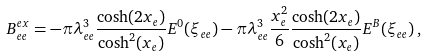<formula> <loc_0><loc_0><loc_500><loc_500>B _ { e e } ^ { e x } = - \pi \lambda _ { e e } ^ { 3 } \frac { \cosh ( 2 x _ { e } ) } { \cosh ^ { 2 } ( x _ { e } ) } E ^ { 0 } ( \xi _ { e e } ) - \pi \lambda _ { e e } ^ { 3 } \frac { x _ { e } ^ { 2 } } { 6 } \frac { \cosh ( 2 x _ { e } ) } { \cosh ^ { 2 } ( x _ { e } ) } E ^ { B } ( \xi _ { e e } ) \, ,</formula> 